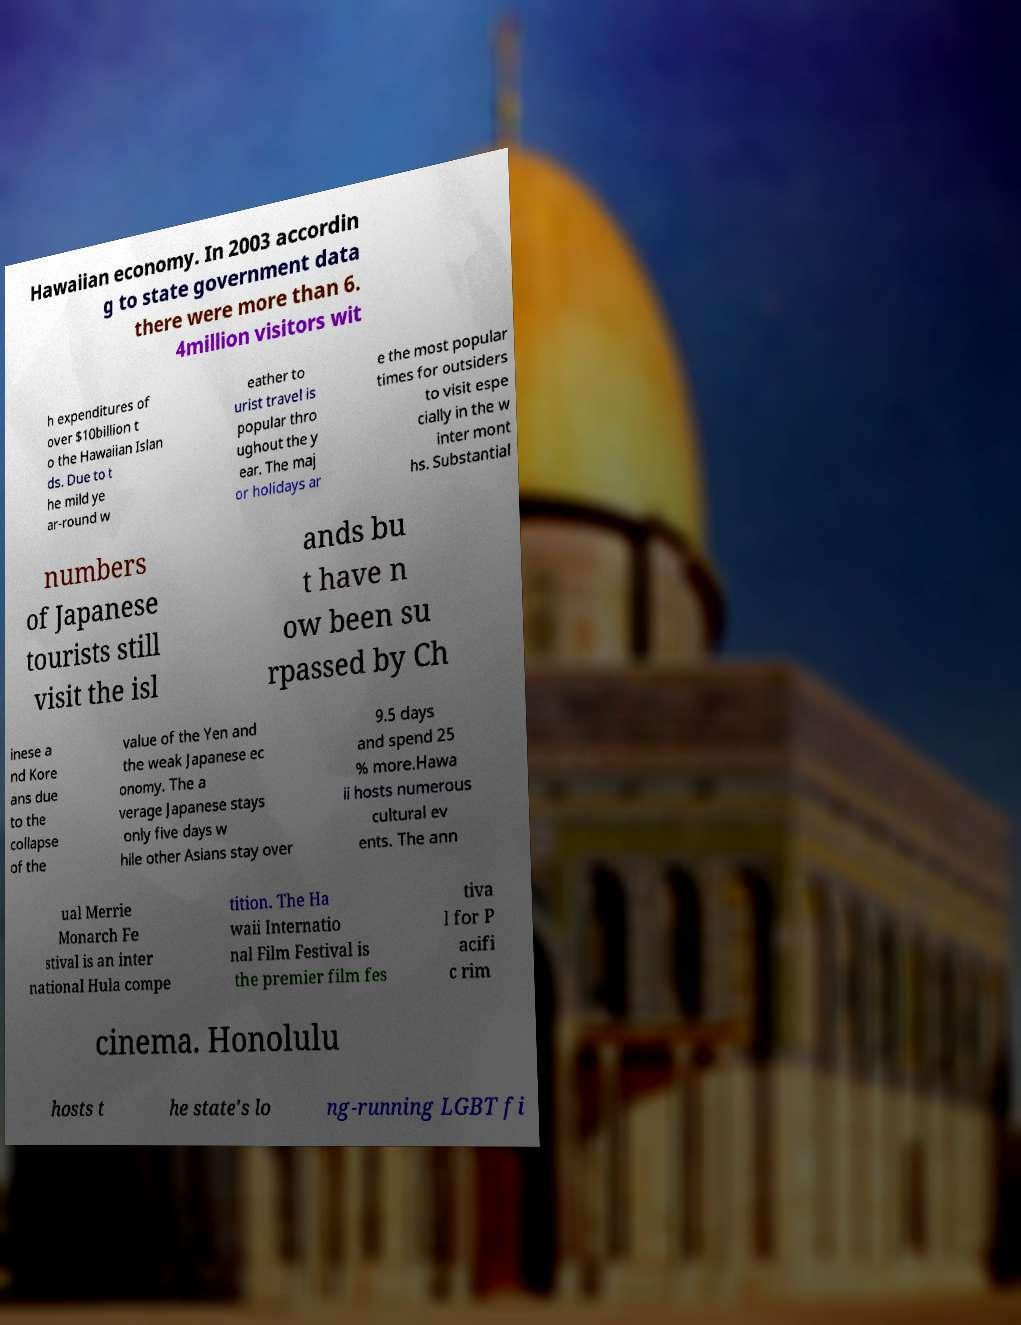What messages or text are displayed in this image? I need them in a readable, typed format. Hawaiian economy. In 2003 accordin g to state government data there were more than 6. 4million visitors wit h expenditures of over $10billion t o the Hawaiian Islan ds. Due to t he mild ye ar-round w eather to urist travel is popular thro ughout the y ear. The maj or holidays ar e the most popular times for outsiders to visit espe cially in the w inter mont hs. Substantial numbers of Japanese tourists still visit the isl ands bu t have n ow been su rpassed by Ch inese a nd Kore ans due to the collapse of the value of the Yen and the weak Japanese ec onomy. The a verage Japanese stays only five days w hile other Asians stay over 9.5 days and spend 25 % more.Hawa ii hosts numerous cultural ev ents. The ann ual Merrie Monarch Fe stival is an inter national Hula compe tition. The Ha waii Internatio nal Film Festival is the premier film fes tiva l for P acifi c rim cinema. Honolulu hosts t he state's lo ng-running LGBT fi 